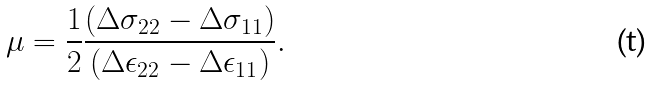Convert formula to latex. <formula><loc_0><loc_0><loc_500><loc_500>\mu = \frac { 1 } { 2 } \frac { ( \Delta \sigma _ { 2 2 } - \Delta \sigma _ { 1 1 } ) } { ( \Delta \epsilon _ { 2 2 } - \Delta \epsilon _ { 1 1 } ) } .</formula> 